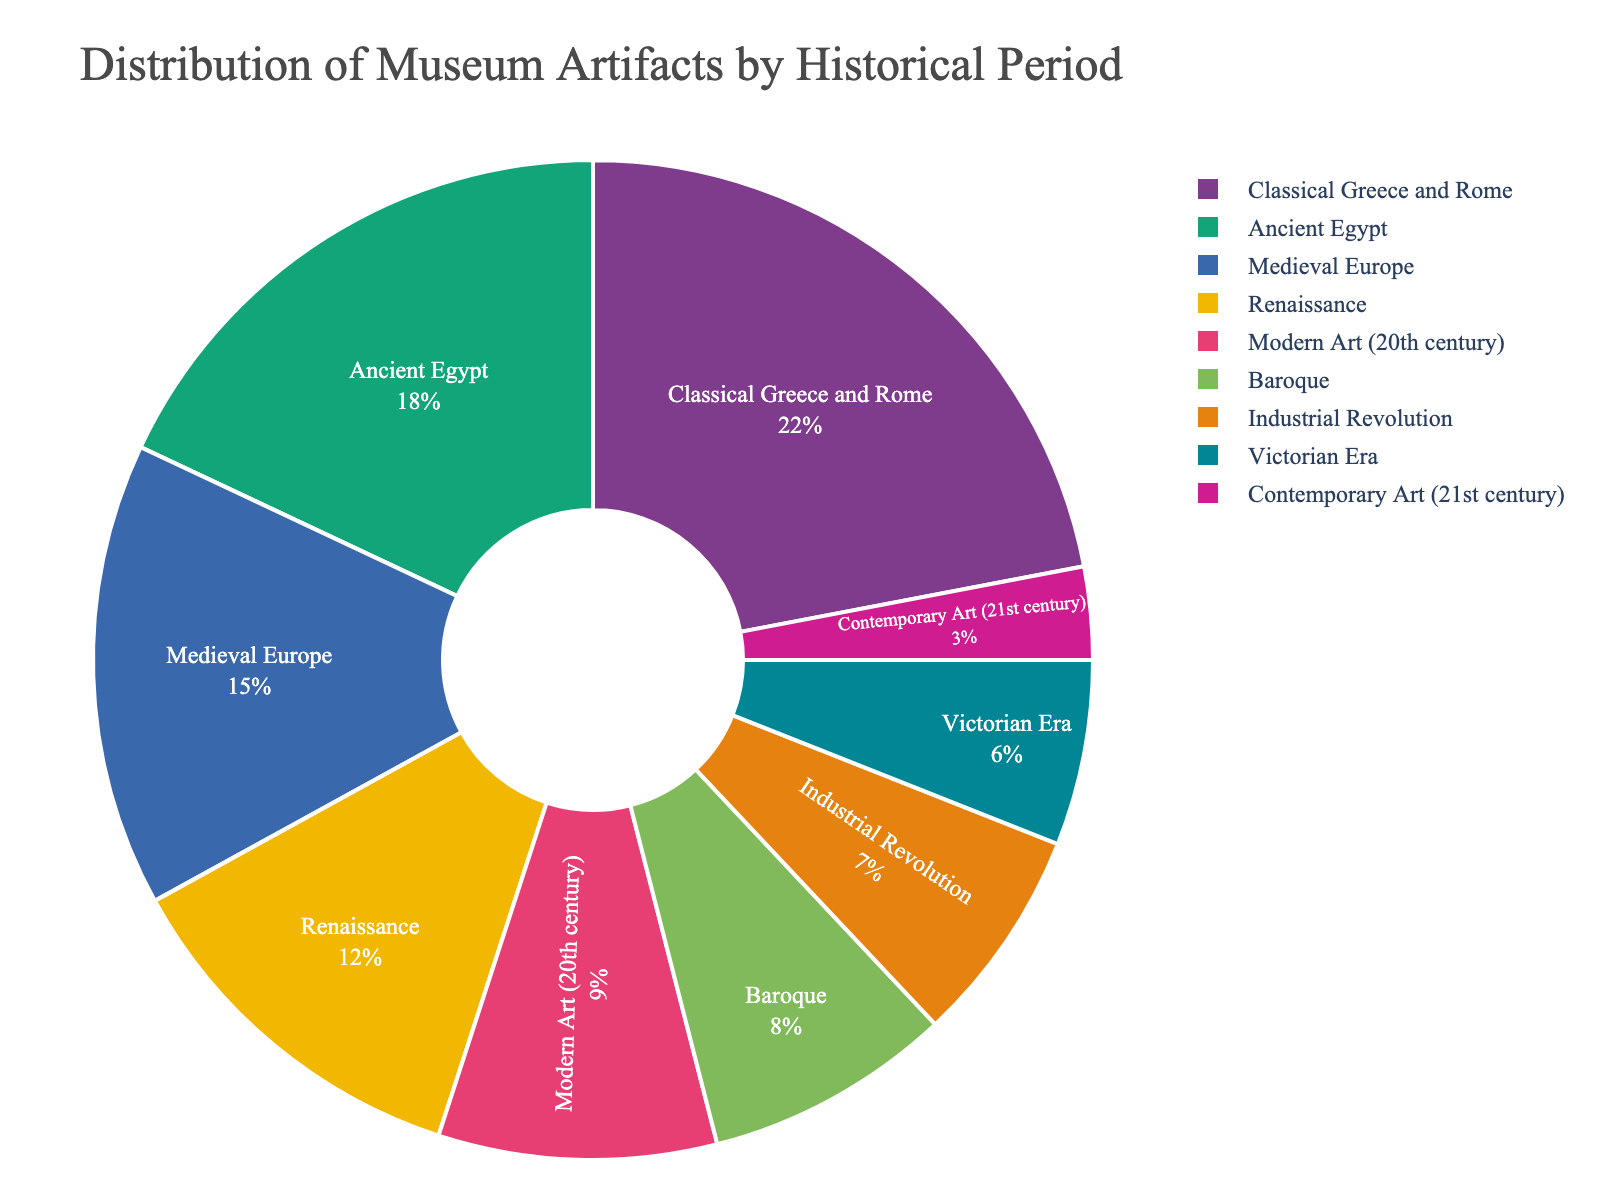Which historical period has the highest percentage of artifacts? The figure shows the distribution of museum artifacts by historical period, and the largest segment indicates the highest percentage. The Classical Greece and Rome period has the highest percentage.
Answer: Classical Greece and Rome Which three historical periods account for the smallest share of artifacts combined? By looking at the smallest segments in the pie chart, we identify the periods. Adding their percentages gives us the combined share. The smallest segments represent the Contemporary Art (3%), Victorian Era (6%), and Industrial Revolution (7%) periods.
Answer: Contemporary Art, Victorian Era, Industrial Revolution How does the percentage of artifacts from Ancient Egypt compare to those from the Renaissance? The pie chart shows the percentages of both periods. Ancient Egypt is 18% and the Renaissance is 12%, so Ancient Egypt has a higher percentage of artifacts.
Answer: Ancient Egypt > Renaissance What is the total percentage of artifacts from periods before the Renaissance (up to Medieval Europe)? Sum the percentages of Ancient Egypt (18%), Classical Greece and Rome (22%), and Medieval Europe (15%). The total is 18% + 22% + 15% = 55%.
Answer: 55% Is the percentage of artifacts from Modern Art (20th century) greater than or lesser than that from Baroque? Compare the percentages shown in the chart: Modern Art is 9% and Baroque is 8%. Hence, Modern Art has a slightly higher share.
Answer: Greater than Which period is represented by the segment in pastel colors, and what is its percentage? Among the pastel colors, we identify the specific color and corresponding label. The Baroque period is displayed in pastel colors, and its percentage is 8%.
Answer: Baroque, 8% What is the difference in the artifact distribution percentages between the Classical Greece and Rome and Industrial Revolution periods? Subtract the smaller segment's percentage (Industrial Revolution) from the larger segment's percentage (Classical Greece and Rome), giving 22% - 7% = 15%.
Answer: 15% What is the average percentage of artifacts from the Baroque and Victorian Era periods? Sum the percentages of both periods and divide by 2. The average is (8% + 6%) / 2 = 7%.
Answer: 7% What is the combined percentage of artifacts from artistic periods (Renaissance and later)? Sum the percentages from the Renaissance, Baroque, Industrial Revolution, Victorian Era, Modern Art (20th century), and Contemporary Art (21st century). The total is 12% + 8% + 7% + 6% + 9% + 3% = 45%.
Answer: 45% 